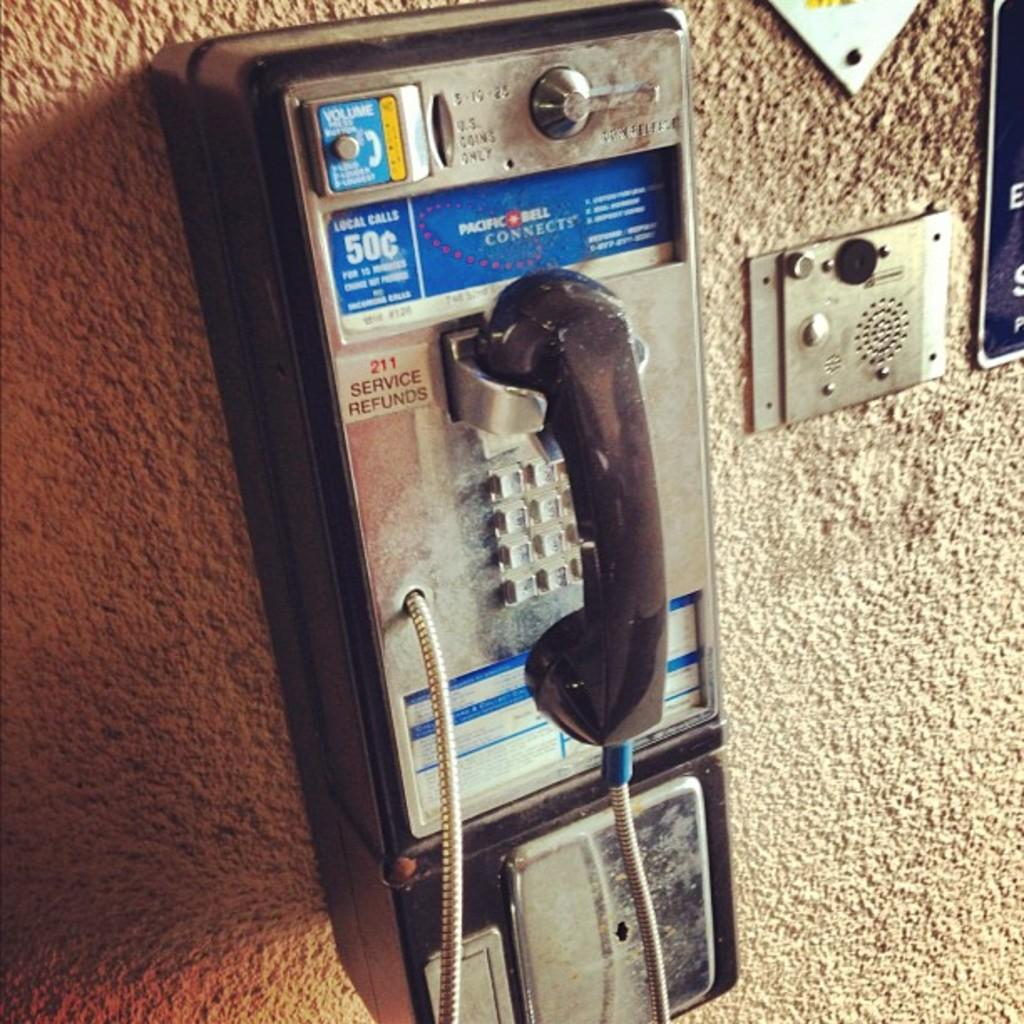What object is present in the image that is used for communication? There is a telephone in the image. Where is the telephone located in the image? The telephone is mounted on the wall. What type of protest is taking place in the image? There is no protest present in the image; it only features a telephone mounted on the wall. 